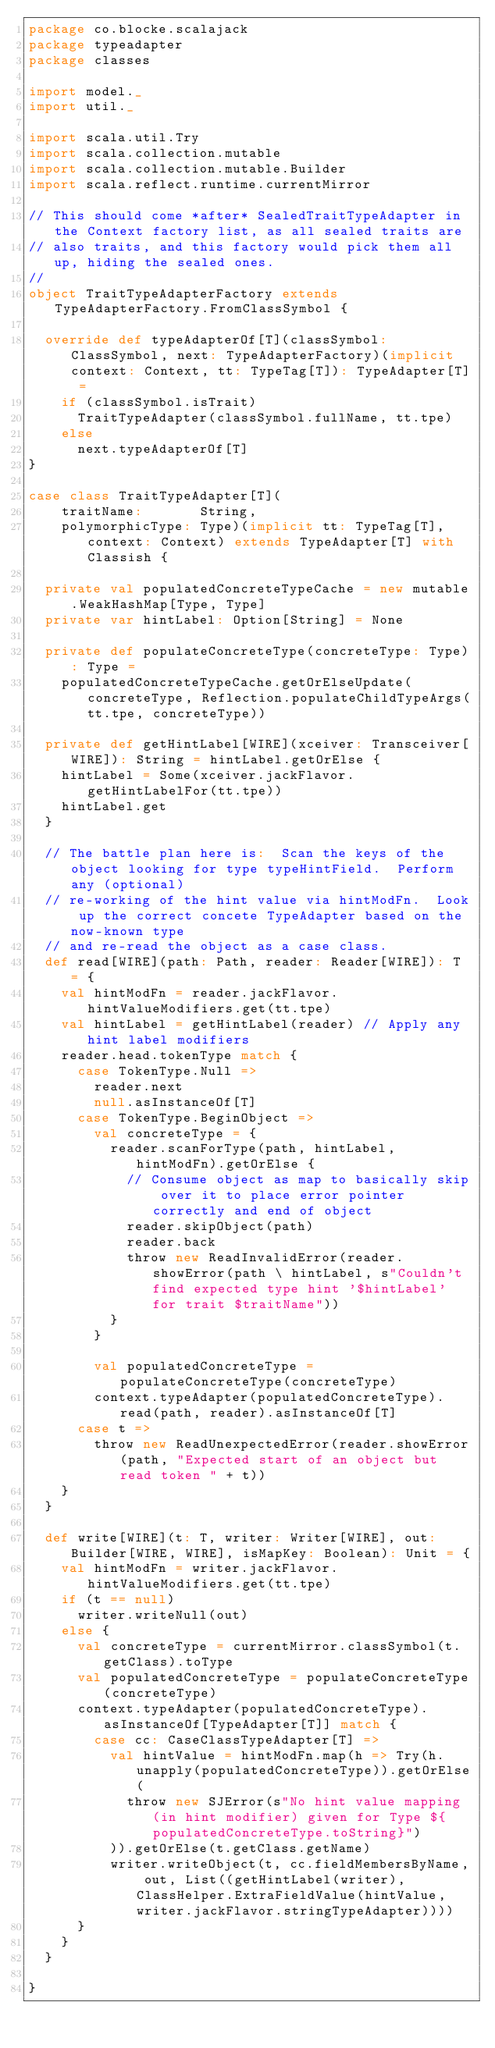<code> <loc_0><loc_0><loc_500><loc_500><_Scala_>package co.blocke.scalajack
package typeadapter
package classes

import model._
import util._

import scala.util.Try
import scala.collection.mutable
import scala.collection.mutable.Builder
import scala.reflect.runtime.currentMirror

// This should come *after* SealedTraitTypeAdapter in the Context factory list, as all sealed traits are
// also traits, and this factory would pick them all up, hiding the sealed ones.
//
object TraitTypeAdapterFactory extends TypeAdapterFactory.FromClassSymbol {

  override def typeAdapterOf[T](classSymbol: ClassSymbol, next: TypeAdapterFactory)(implicit context: Context, tt: TypeTag[T]): TypeAdapter[T] =
    if (classSymbol.isTrait)
      TraitTypeAdapter(classSymbol.fullName, tt.tpe)
    else
      next.typeAdapterOf[T]
}

case class TraitTypeAdapter[T](
    traitName:       String,
    polymorphicType: Type)(implicit tt: TypeTag[T], context: Context) extends TypeAdapter[T] with Classish {

  private val populatedConcreteTypeCache = new mutable.WeakHashMap[Type, Type]
  private var hintLabel: Option[String] = None

  private def populateConcreteType(concreteType: Type): Type =
    populatedConcreteTypeCache.getOrElseUpdate(concreteType, Reflection.populateChildTypeArgs(tt.tpe, concreteType))

  private def getHintLabel[WIRE](xceiver: Transceiver[WIRE]): String = hintLabel.getOrElse {
    hintLabel = Some(xceiver.jackFlavor.getHintLabelFor(tt.tpe))
    hintLabel.get
  }

  // The battle plan here is:  Scan the keys of the object looking for type typeHintField.  Perform any (optional)
  // re-working of the hint value via hintModFn.  Look up the correct concete TypeAdapter based on the now-known type
  // and re-read the object as a case class.
  def read[WIRE](path: Path, reader: Reader[WIRE]): T = {
    val hintModFn = reader.jackFlavor.hintValueModifiers.get(tt.tpe)
    val hintLabel = getHintLabel(reader) // Apply any hint label modifiers
    reader.head.tokenType match {
      case TokenType.Null =>
        reader.next
        null.asInstanceOf[T]
      case TokenType.BeginObject =>
        val concreteType = {
          reader.scanForType(path, hintLabel, hintModFn).getOrElse {
            // Consume object as map to basically skip over it to place error pointer correctly and end of object
            reader.skipObject(path)
            reader.back
            throw new ReadInvalidError(reader.showError(path \ hintLabel, s"Couldn't find expected type hint '$hintLabel' for trait $traitName"))
          }
        }

        val populatedConcreteType = populateConcreteType(concreteType)
        context.typeAdapter(populatedConcreteType).read(path, reader).asInstanceOf[T]
      case t =>
        throw new ReadUnexpectedError(reader.showError(path, "Expected start of an object but read token " + t))
    }
  }

  def write[WIRE](t: T, writer: Writer[WIRE], out: Builder[WIRE, WIRE], isMapKey: Boolean): Unit = {
    val hintModFn = writer.jackFlavor.hintValueModifiers.get(tt.tpe)
    if (t == null)
      writer.writeNull(out)
    else {
      val concreteType = currentMirror.classSymbol(t.getClass).toType
      val populatedConcreteType = populateConcreteType(concreteType)
      context.typeAdapter(populatedConcreteType).asInstanceOf[TypeAdapter[T]] match {
        case cc: CaseClassTypeAdapter[T] =>
          val hintValue = hintModFn.map(h => Try(h.unapply(populatedConcreteType)).getOrElse(
            throw new SJError(s"No hint value mapping (in hint modifier) given for Type ${populatedConcreteType.toString}")
          )).getOrElse(t.getClass.getName)
          writer.writeObject(t, cc.fieldMembersByName, out, List((getHintLabel(writer), ClassHelper.ExtraFieldValue(hintValue, writer.jackFlavor.stringTypeAdapter))))
      }
    }
  }

}
</code> 